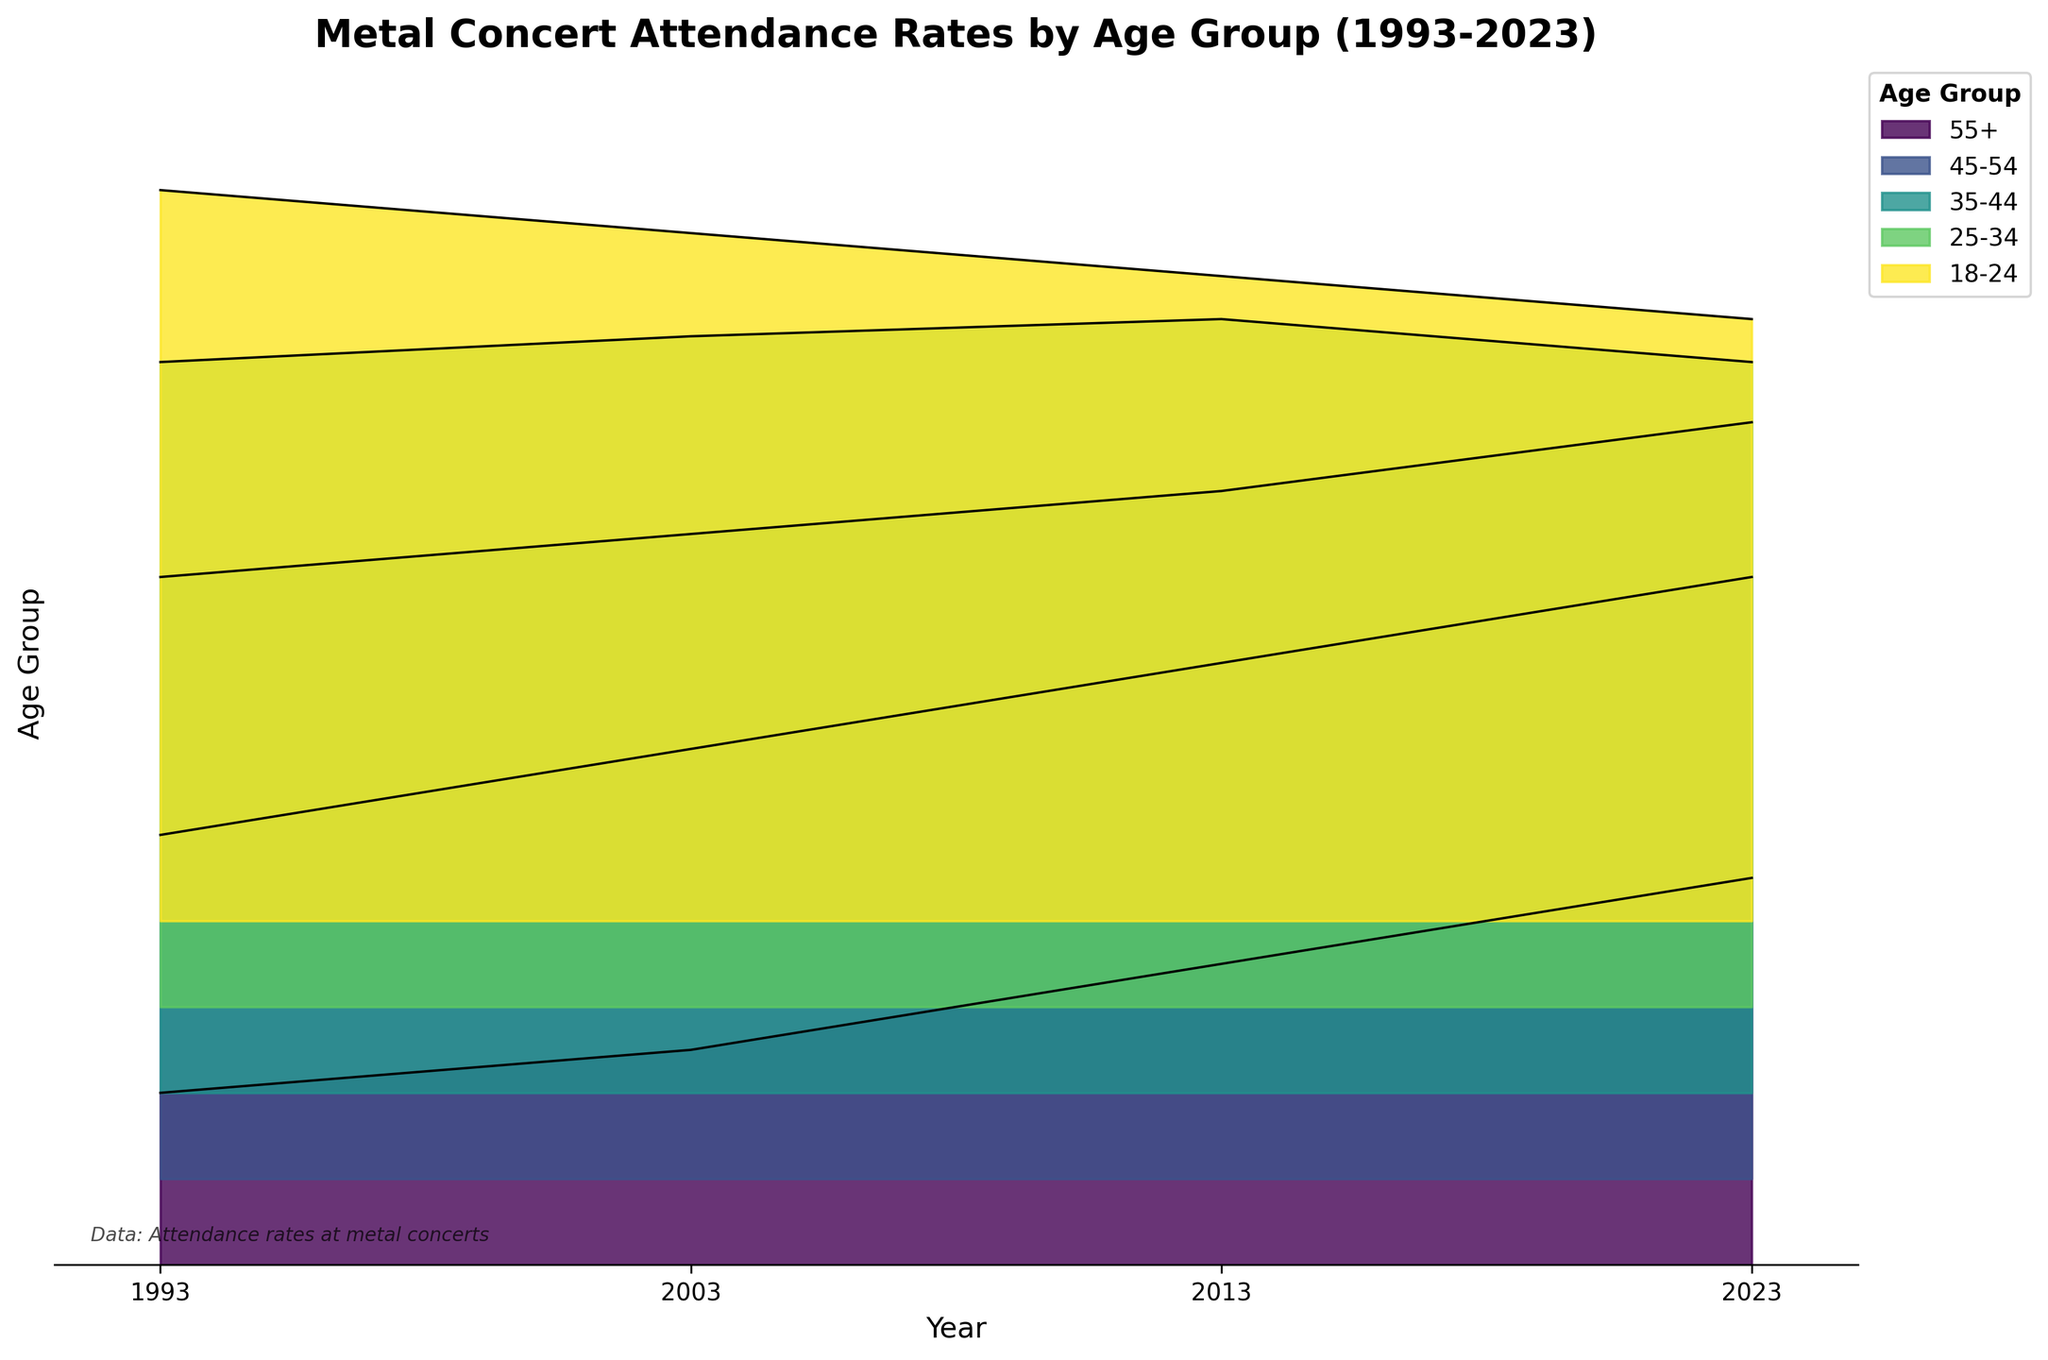What's the title of the figure? The title is the text displayed prominently at the top of the figure. It summarizes what the plot is about. In this case, the title reads "Metal Concert Attendance Rates by Age Group (1993-2023)"
Answer: Metal Concert Attendance Rates by Age Group (1993-2023) Which age group had the lowest attendance rate in 1993? In 1993, the y-values are stacked vertically with the 18-24 age group at the top and the 55+ group at the bottom. By looking at the lowest point for the 1993 segment, we can see that the 55+ age group has the lowest attendance rate of 20.
Answer: 55+ How has the attendance rate for the 35-44 age group changed from 1993 to 2023? We need to look at the 35-44 age group line for both the 1993 and 2023 points. In 1993, the attendance rate is 60, and in 2023, it is 78. The change is found by subtracting 60 from 78.
Answer: Increased by 18 Which year had the highest attendance rate for the 25-34 age group? We compare the attendance rates for the 25-34 age group across all the years. In 2013, the attendance rate is 80, which is the highest compared to other years.
Answer: 2013 In 2023, which age group showed the most significant increase in attendance rate compared to 1993? We compare the attendance rates for all age groups between 1993 and 2023. The differences are 45-54 (+30), 35-44 (+18), and 55+ (+25), 25-34 (+0), and 18-24 (-15). The highest increase is for the 45-54 age group with a growth of 30.
Answer: 45-54 What is the overall trend for attendance rates in the 18-24 age group from 1993 to 2023? Looking at the 18-24 age group from 1993 (85) to 2023 (70), there is a steady decline over the years.
Answer: Decreasing Compare the attendance rates of the 45-54 and 55+ age groups in 2023. Which is higher and by how much? In 2023, the 45-54 age group has an attendance rate of 70, while the 55+ age group has an attendance rate of 45. The difference is 70 minus 45.
Answer: 45-54, by 25 What is the average attendance rate of the 25-34 age group from 1993 to 2023? We sum the attendance rates for the 25-34 age group (75 + 78 + 80 + 75 = 308) and divide by the number of years recorded (4).
Answer: 77 Which age group consistently shows an increase in attendance rate across all years? We consider each age group and check the attendance rates in 1993, 2003, 2013, and 2023. The 45-54 age group increased over all periods (40 in 1993, 50 in 2003, 60 in 2013, 70 in 2023).
Answer: 45-54 Is there any age group whose attendance rate never decreased over the past 30 years? Checking each group's rates from 1993 to 2023, only the 45-54 age group shows consistent growth without any decrease.
Answer: 45-54 